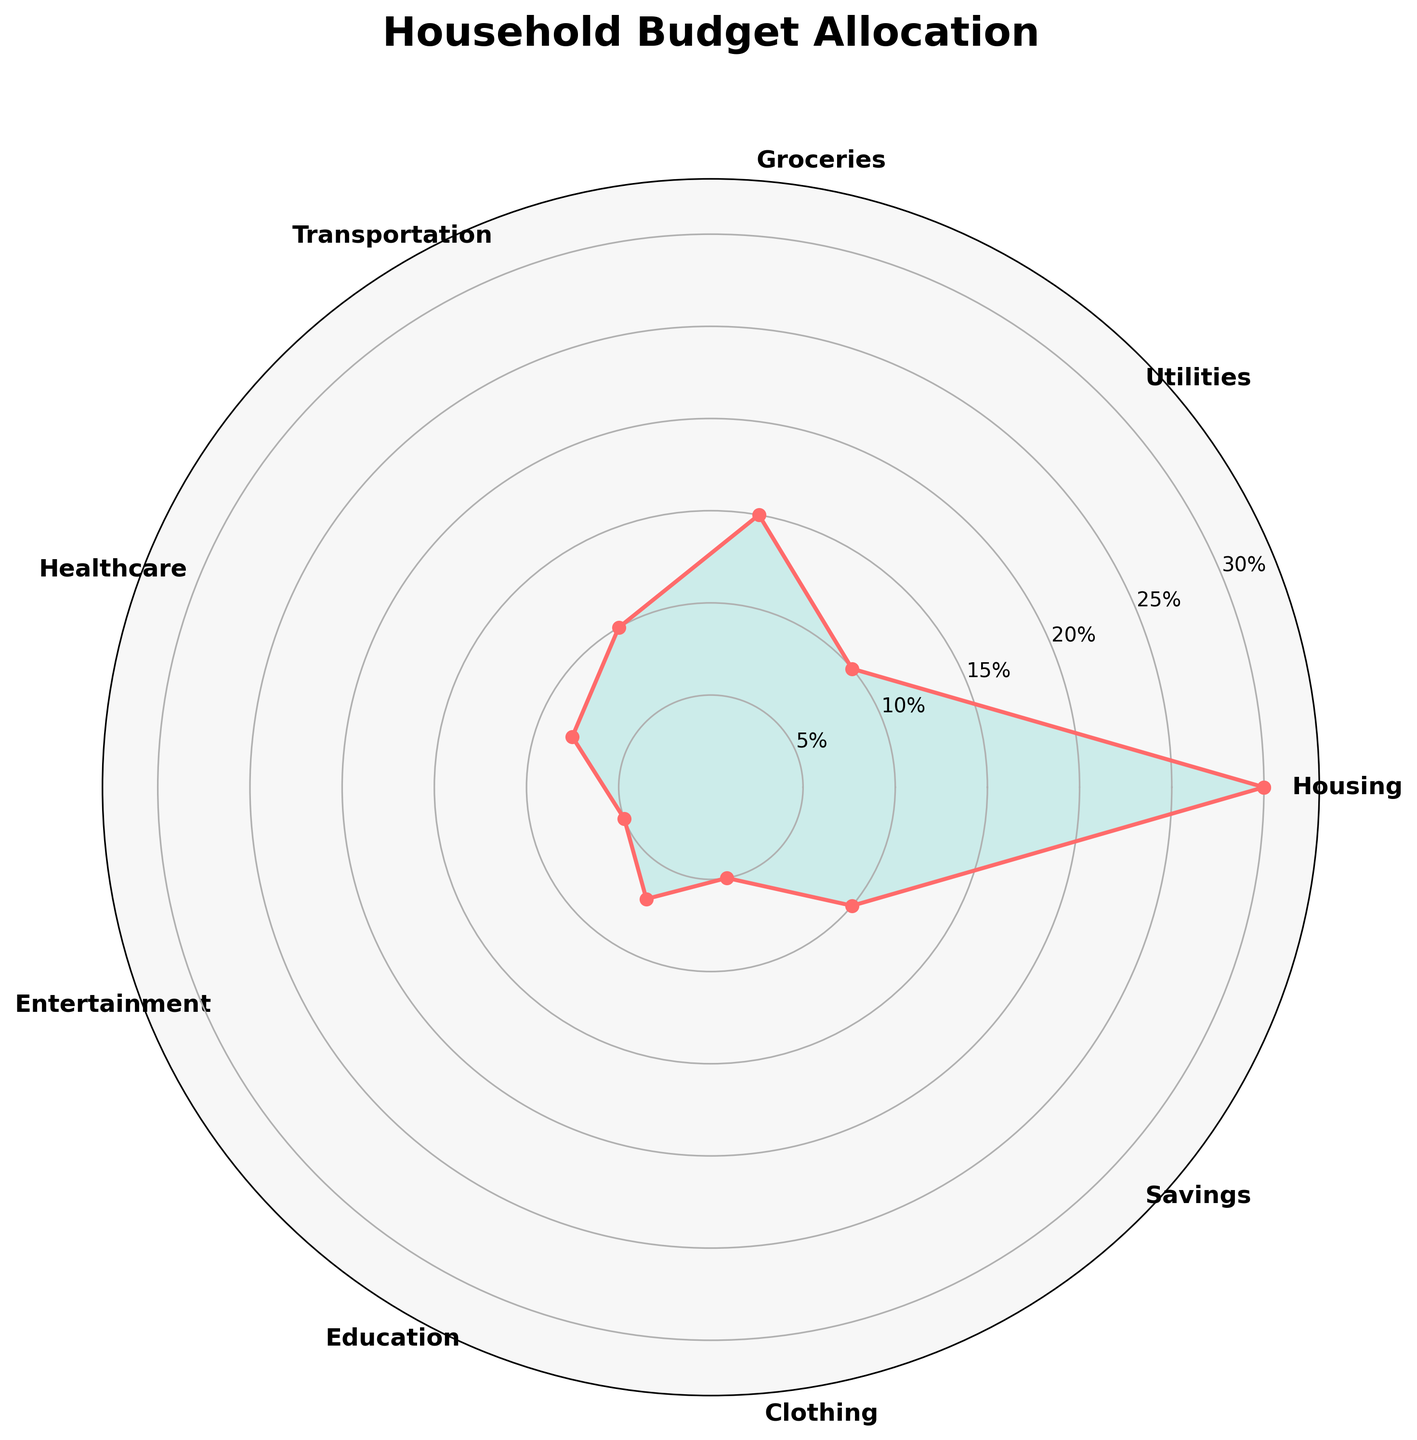What's the title of the rose chart? The title of a chart is typically displayed at the top above the plot. In this case, the title is "Household Budget Allocation" as mentioned in the code comments.
Answer: Household Budget Allocation How many expense categories are represented in the chart? The chart has labels for different segments, each representing an expense category. By counting them, we can see there are 9 segments.
Answer: 9 Which expense category is allocated the highest percentage of the household budget? The segment with the largest radial length corresponds to the highest percentage. In this case, "Housing" takes up the largest segment at 30%.
Answer: Housing What is the combined percentage allocated to Utilities, Groceries, and Transportation? By looking at the chart and summing the percentages for Utilities (10%), Groceries (15%), and Transportation (10%), the total is 10% + 15% + 10% = 35%.
Answer: 35% Which two expense categories have an equal allocation of 5%? The segments labeled "Entertainment" and "Clothing" both extend to the same radial length, indicating they each account for 5% of the budget.
Answer: Entertainment and Clothing Is the allocation for Healthcare greater than for Education? By comparing the radial lengths or percentages, Healthcare is allocated 8%, while Education receives 7%, so Healthcare has a greater allocation.
Answer: Yes Which expense category stands between Education and Savings in the chart's radial arrangement? By following the sequence of categories in the radial order, the category that lies between "Education" and "Savings" is "Clothing".
Answer: Clothing Which categories have a total allocation equal to Healthcare's percentage? Healthcare is allocated 8%. The categories with allocations of 7% (Education) and 1% (not visible in this chart, but hypothetical addition) are needed to sum to 8%. Since there is no such combination, we can only infer Education alone nearly matches.
Answer: None or Education (almost) If you wanted to reduce the budget for Housing by 10%, how would that affect the chart? Reducing Housing's allocation from 30% by 10% would make it 27%. The segment for Housing would shrink slightly, and the radial length for Housing would be shorter, affecting visual comparison.
Answer: Housing would decrease to 27% How does the Savings category compare with Utilities in terms of budget allocation? Both Savings and Utilities have the same percentage allocation of 10%, meaning their segments are of equal radial length in the chart.
Answer: Equal 